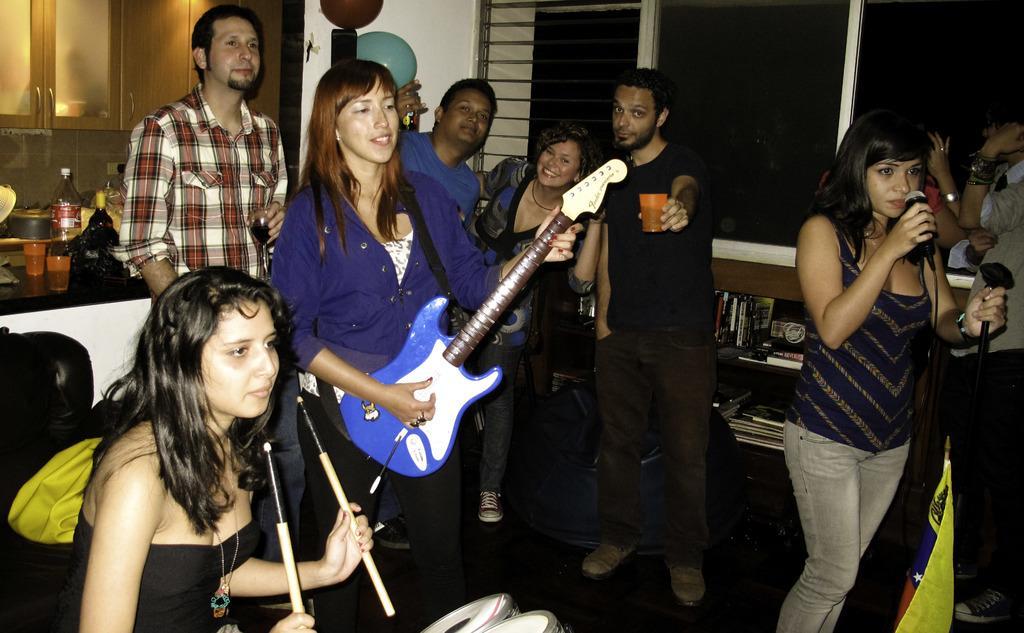Can you describe this image briefly? This picture is taken inside the room, There are some people standing and holding music instruments and in the right side there is a woman siting and holding two sticks and in hte background there is brown color doors and in the right side there is a black color window. 